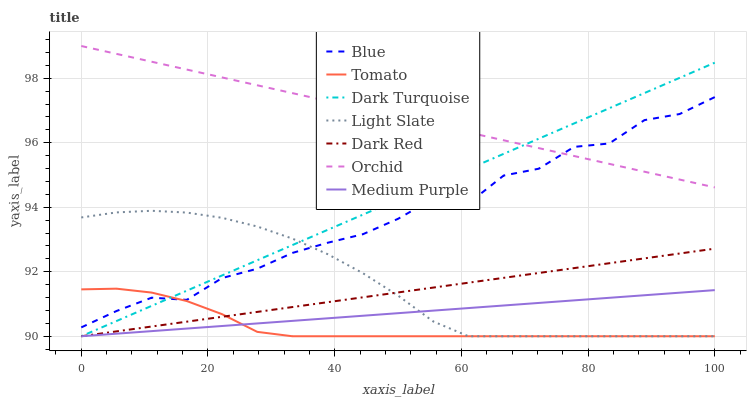Does Tomato have the minimum area under the curve?
Answer yes or no. Yes. Does Orchid have the maximum area under the curve?
Answer yes or no. Yes. Does Light Slate have the minimum area under the curve?
Answer yes or no. No. Does Light Slate have the maximum area under the curve?
Answer yes or no. No. Is Medium Purple the smoothest?
Answer yes or no. Yes. Is Blue the roughest?
Answer yes or no. Yes. Is Tomato the smoothest?
Answer yes or no. No. Is Tomato the roughest?
Answer yes or no. No. Does Tomato have the lowest value?
Answer yes or no. Yes. Does Orchid have the lowest value?
Answer yes or no. No. Does Orchid have the highest value?
Answer yes or no. Yes. Does Tomato have the highest value?
Answer yes or no. No. Is Light Slate less than Orchid?
Answer yes or no. Yes. Is Blue greater than Dark Red?
Answer yes or no. Yes. Does Dark Red intersect Light Slate?
Answer yes or no. Yes. Is Dark Red less than Light Slate?
Answer yes or no. No. Is Dark Red greater than Light Slate?
Answer yes or no. No. Does Light Slate intersect Orchid?
Answer yes or no. No. 